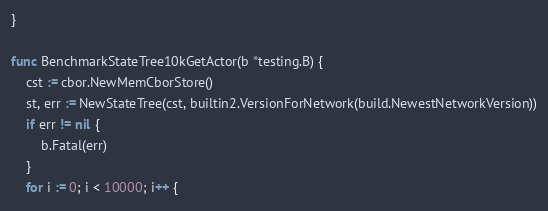<code> <loc_0><loc_0><loc_500><loc_500><_Go_>}

func BenchmarkStateTree10kGetActor(b *testing.B) {
	cst := cbor.NewMemCborStore()
	st, err := NewStateTree(cst, builtin2.VersionForNetwork(build.NewestNetworkVersion))
	if err != nil {
		b.Fatal(err)
	}
	for i := 0; i < 10000; i++ {</code> 